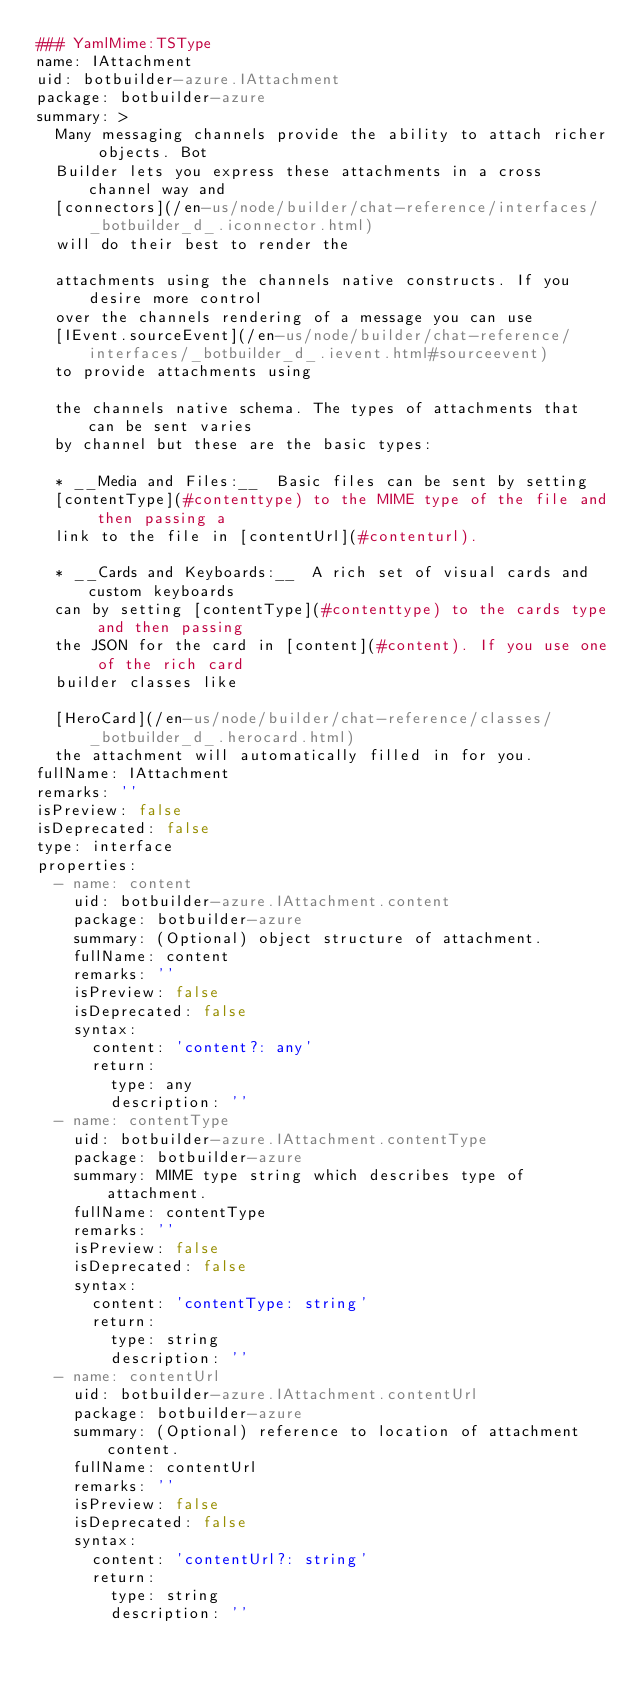Convert code to text. <code><loc_0><loc_0><loc_500><loc_500><_YAML_>### YamlMime:TSType
name: IAttachment
uid: botbuilder-azure.IAttachment
package: botbuilder-azure
summary: >
  Many messaging channels provide the ability to attach richer objects. Bot
  Builder lets you express these attachments in a cross channel way and
  [connectors](/en-us/node/builder/chat-reference/interfaces/_botbuilder_d_.iconnector.html)
  will do their best to render the

  attachments using the channels native constructs. If you desire more control
  over the channels rendering of a message you can use
  [IEvent.sourceEvent](/en-us/node/builder/chat-reference/interfaces/_botbuilder_d_.ievent.html#sourceevent)
  to provide attachments using

  the channels native schema. The types of attachments that can be sent varies
  by channel but these are the basic types:

  * __Media and Files:__  Basic files can be sent by setting
  [contentType](#contenttype) to the MIME type of the file and then passing a
  link to the file in [contentUrl](#contenturl).

  * __Cards and Keyboards:__  A rich set of visual cards and custom keyboards
  can by setting [contentType](#contenttype) to the cards type and then passing
  the JSON for the card in [content](#content). If you use one of the rich card
  builder classes like

  [HeroCard](/en-us/node/builder/chat-reference/classes/_botbuilder_d_.herocard.html)
  the attachment will automatically filled in for you.
fullName: IAttachment
remarks: ''
isPreview: false
isDeprecated: false
type: interface
properties:
  - name: content
    uid: botbuilder-azure.IAttachment.content
    package: botbuilder-azure
    summary: (Optional) object structure of attachment.
    fullName: content
    remarks: ''
    isPreview: false
    isDeprecated: false
    syntax:
      content: 'content?: any'
      return:
        type: any
        description: ''
  - name: contentType
    uid: botbuilder-azure.IAttachment.contentType
    package: botbuilder-azure
    summary: MIME type string which describes type of attachment.
    fullName: contentType
    remarks: ''
    isPreview: false
    isDeprecated: false
    syntax:
      content: 'contentType: string'
      return:
        type: string
        description: ''
  - name: contentUrl
    uid: botbuilder-azure.IAttachment.contentUrl
    package: botbuilder-azure
    summary: (Optional) reference to location of attachment content.
    fullName: contentUrl
    remarks: ''
    isPreview: false
    isDeprecated: false
    syntax:
      content: 'contentUrl?: string'
      return:
        type: string
        description: ''
</code> 